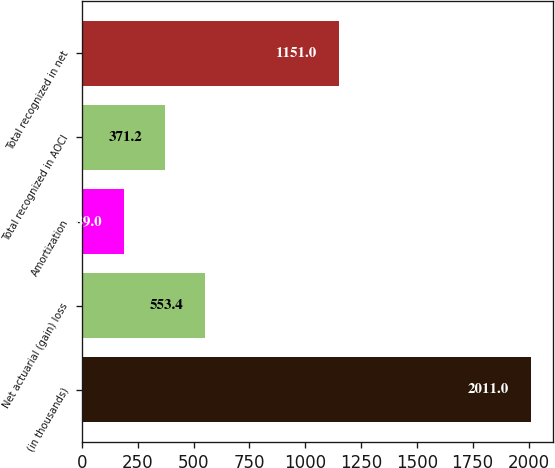<chart> <loc_0><loc_0><loc_500><loc_500><bar_chart><fcel>(in thousands)<fcel>Net actuarial (gain) loss<fcel>Amortization<fcel>Total recognized in AOCI<fcel>Total recognized in net<nl><fcel>2011<fcel>553.4<fcel>189<fcel>371.2<fcel>1151<nl></chart> 